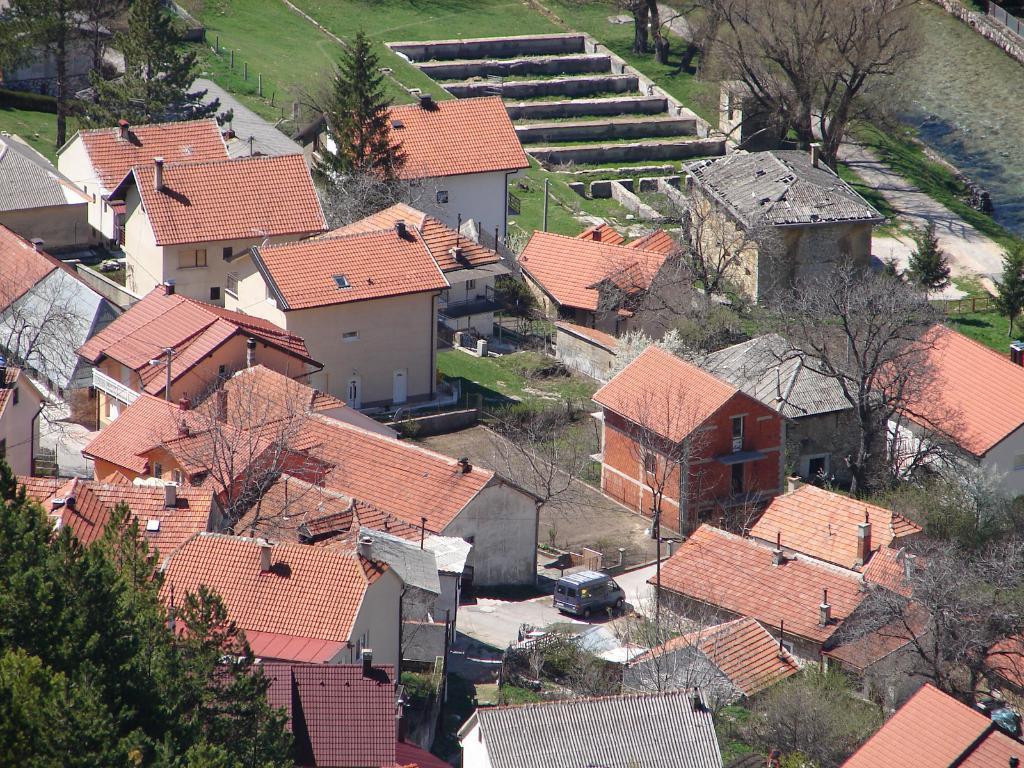Please provide a concise description of this image. In the image we can see there are trees and hut shaped buildings. There is car parked on the road and there are stairs. Behind the ground is covered with grass and there is water. 